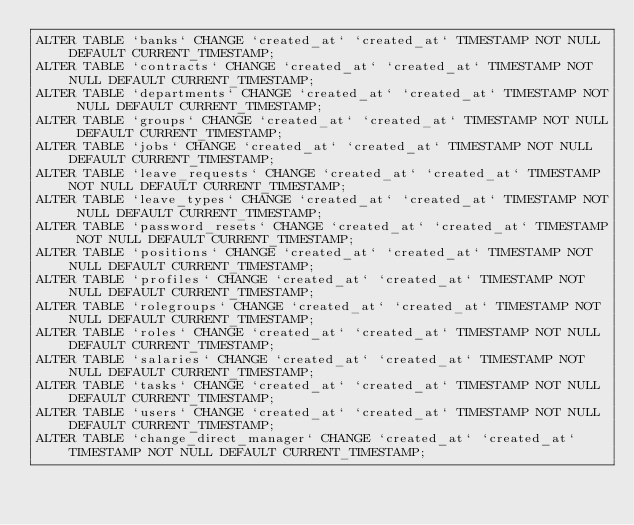Convert code to text. <code><loc_0><loc_0><loc_500><loc_500><_SQL_>ALTER TABLE `banks` CHANGE `created_at` `created_at` TIMESTAMP NOT NULL DEFAULT CURRENT_TIMESTAMP;
ALTER TABLE `contracts` CHANGE `created_at` `created_at` TIMESTAMP NOT NULL DEFAULT CURRENT_TIMESTAMP;
ALTER TABLE `departments` CHANGE `created_at` `created_at` TIMESTAMP NOT NULL DEFAULT CURRENT_TIMESTAMP;
ALTER TABLE `groups` CHANGE `created_at` `created_at` TIMESTAMP NOT NULL DEFAULT CURRENT_TIMESTAMP;
ALTER TABLE `jobs` CHANGE `created_at` `created_at` TIMESTAMP NOT NULL DEFAULT CURRENT_TIMESTAMP;
ALTER TABLE `leave_requests` CHANGE `created_at` `created_at` TIMESTAMP NOT NULL DEFAULT CURRENT_TIMESTAMP;
ALTER TABLE `leave_types` CHANGE `created_at` `created_at` TIMESTAMP NOT NULL DEFAULT CURRENT_TIMESTAMP;
ALTER TABLE `password_resets` CHANGE `created_at` `created_at` TIMESTAMP NOT NULL DEFAULT CURRENT_TIMESTAMP;
ALTER TABLE `positions` CHANGE `created_at` `created_at` TIMESTAMP NOT NULL DEFAULT CURRENT_TIMESTAMP;
ALTER TABLE `profiles` CHANGE `created_at` `created_at` TIMESTAMP NOT NULL DEFAULT CURRENT_TIMESTAMP;
ALTER TABLE `rolegroups` CHANGE `created_at` `created_at` TIMESTAMP NOT NULL DEFAULT CURRENT_TIMESTAMP;
ALTER TABLE `roles` CHANGE `created_at` `created_at` TIMESTAMP NOT NULL DEFAULT CURRENT_TIMESTAMP;
ALTER TABLE `salaries` CHANGE `created_at` `created_at` TIMESTAMP NOT NULL DEFAULT CURRENT_TIMESTAMP;
ALTER TABLE `tasks` CHANGE `created_at` `created_at` TIMESTAMP NOT NULL DEFAULT CURRENT_TIMESTAMP;
ALTER TABLE `users` CHANGE `created_at` `created_at` TIMESTAMP NOT NULL DEFAULT CURRENT_TIMESTAMP;
ALTER TABLE `change_direct_manager` CHANGE `created_at` `created_at` TIMESTAMP NOT NULL DEFAULT CURRENT_TIMESTAMP;


</code> 